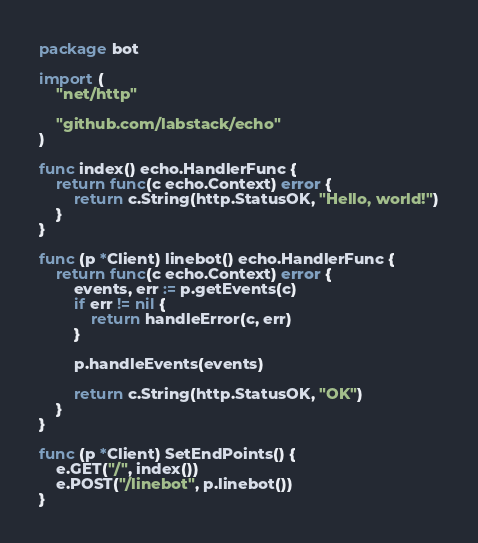Convert code to text. <code><loc_0><loc_0><loc_500><loc_500><_Go_>package bot

import (
	"net/http"

	"github.com/labstack/echo"
)

func index() echo.HandlerFunc {
	return func(c echo.Context) error {
		return c.String(http.StatusOK, "Hello, world!")
	}
}

func (p *Client) linebot() echo.HandlerFunc {
	return func(c echo.Context) error {
		events, err := p.getEvents(c)
		if err != nil {
			return handleError(c, err)
		}

		p.handleEvents(events)

		return c.String(http.StatusOK, "OK")
	}
}

func (p *Client) SetEndPoints() {
	e.GET("/", index())
	e.POST("/linebot", p.linebot())
}
</code> 